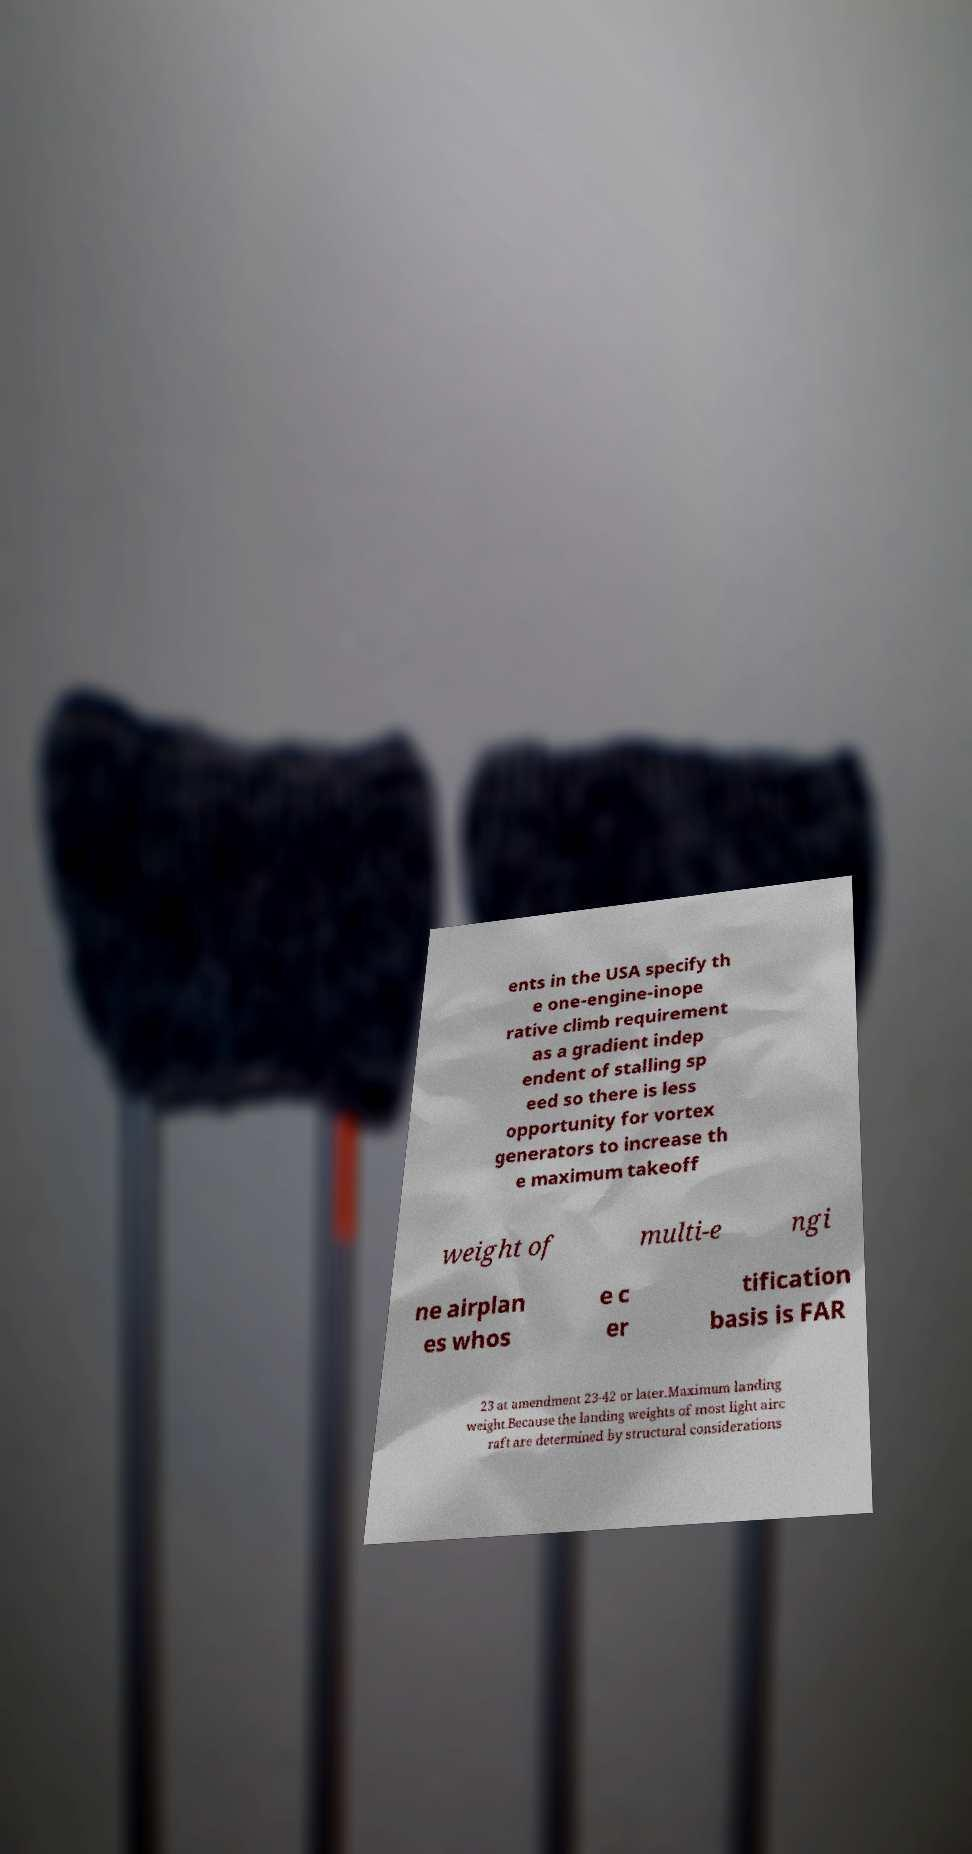Please read and relay the text visible in this image. What does it say? ents in the USA specify th e one-engine-inope rative climb requirement as a gradient indep endent of stalling sp eed so there is less opportunity for vortex generators to increase th e maximum takeoff weight of multi-e ngi ne airplan es whos e c er tification basis is FAR 23 at amendment 23-42 or later.Maximum landing weight.Because the landing weights of most light airc raft are determined by structural considerations 